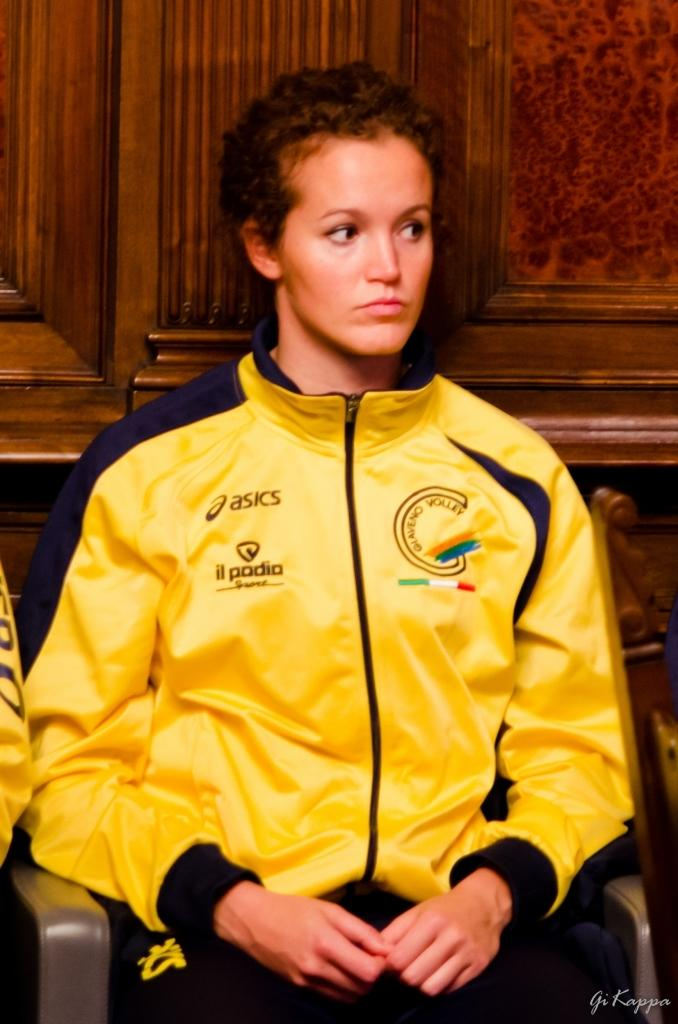<image>
Render a clear and concise summary of the photo. A young woman listening very intently to someone while wearing an asics jacket with an il podia Sport logo. 